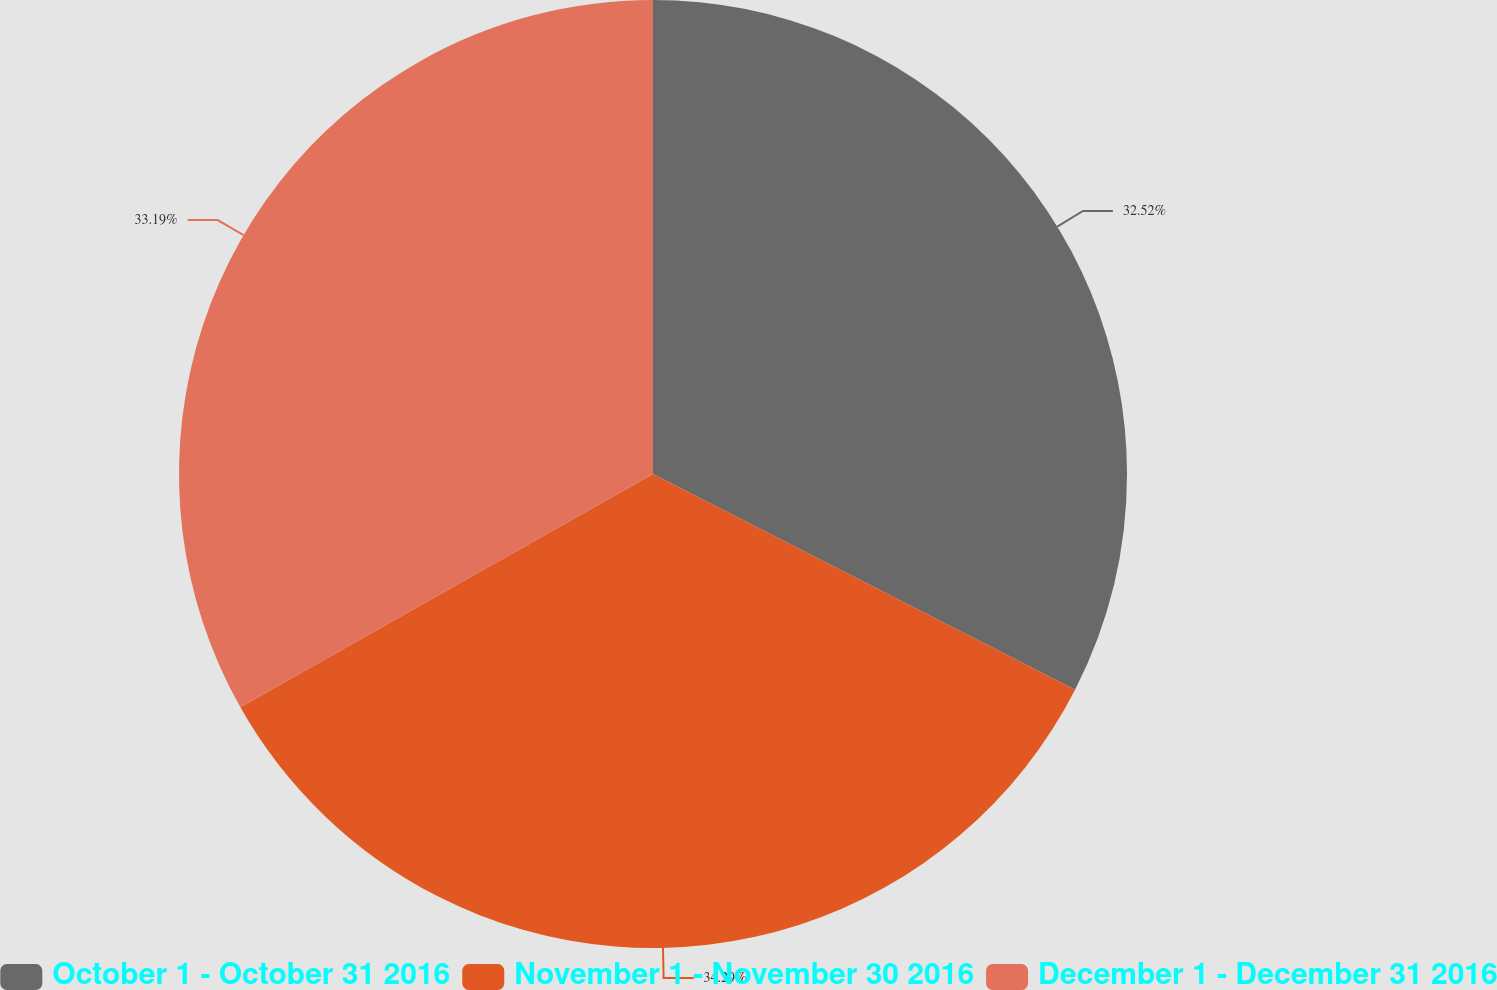Convert chart. <chart><loc_0><loc_0><loc_500><loc_500><pie_chart><fcel>October 1 - October 31 2016<fcel>November 1 - November 30 2016<fcel>December 1 - December 31 2016<nl><fcel>32.52%<fcel>34.29%<fcel>33.19%<nl></chart> 